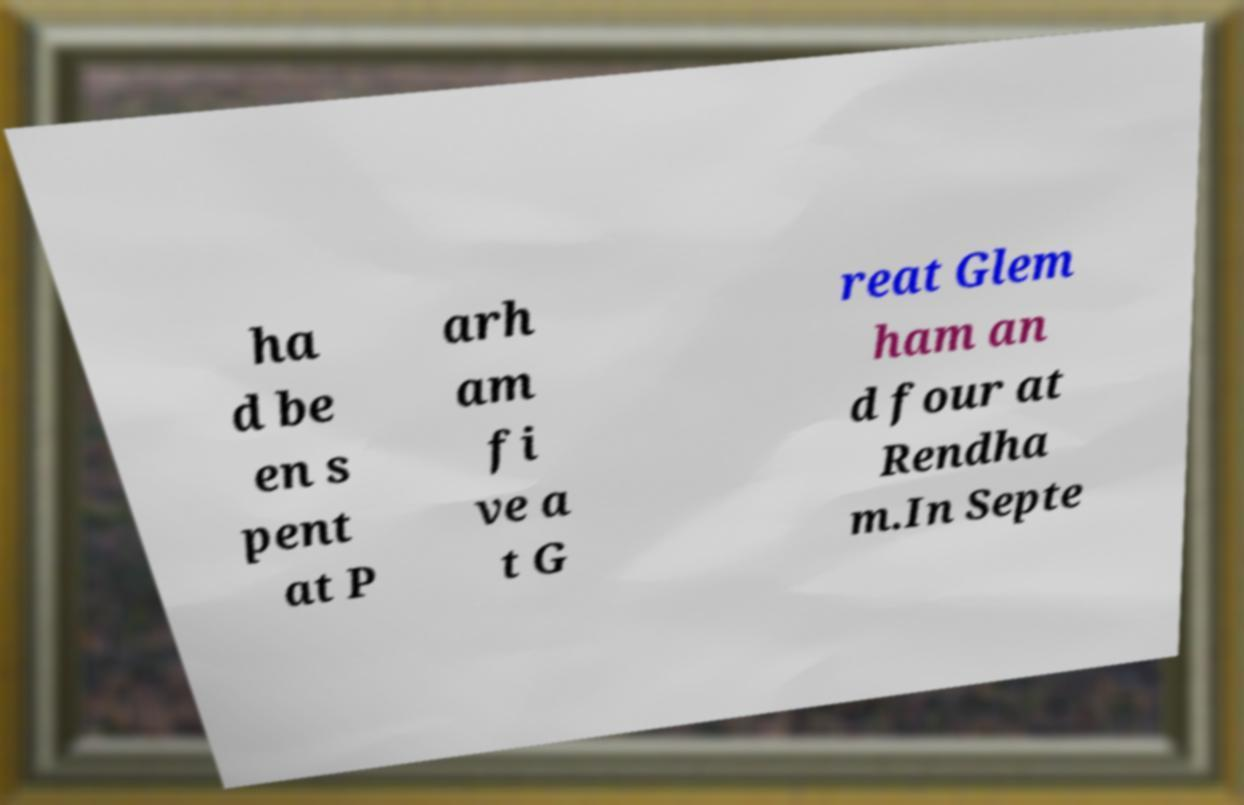I need the written content from this picture converted into text. Can you do that? ha d be en s pent at P arh am fi ve a t G reat Glem ham an d four at Rendha m.In Septe 